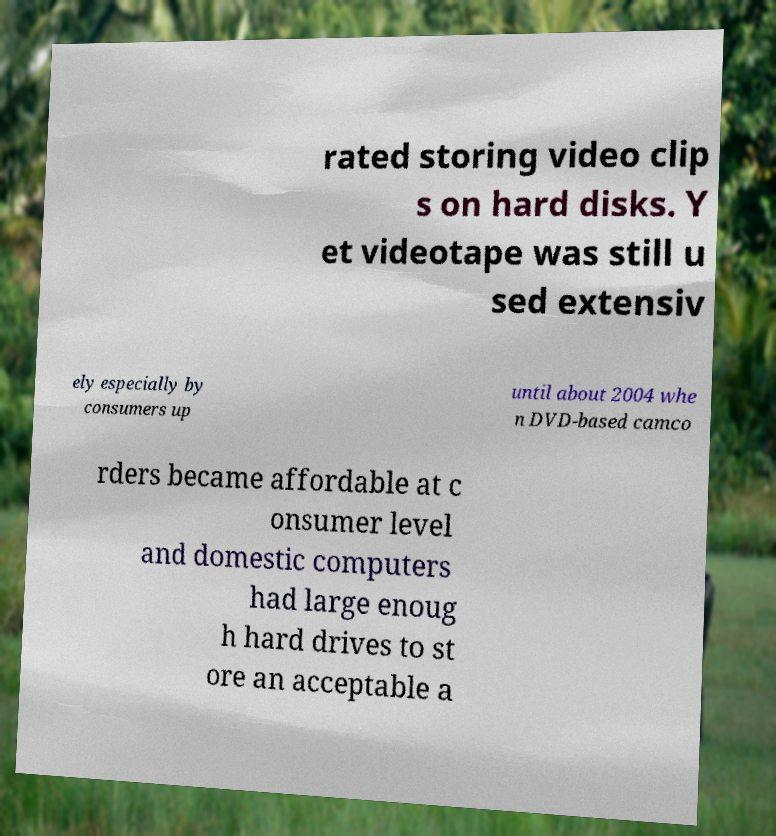Can you read and provide the text displayed in the image?This photo seems to have some interesting text. Can you extract and type it out for me? rated storing video clip s on hard disks. Y et videotape was still u sed extensiv ely especially by consumers up until about 2004 whe n DVD-based camco rders became affordable at c onsumer level and domestic computers had large enoug h hard drives to st ore an acceptable a 